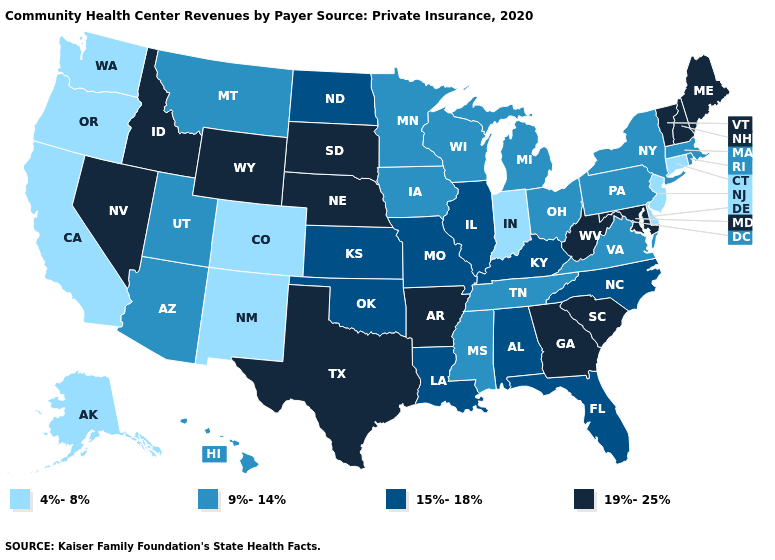Among the states that border New Hampshire , which have the lowest value?
Short answer required. Massachusetts. Does the first symbol in the legend represent the smallest category?
Answer briefly. Yes. Does Connecticut have a lower value than Delaware?
Quick response, please. No. Name the states that have a value in the range 19%-25%?
Give a very brief answer. Arkansas, Georgia, Idaho, Maine, Maryland, Nebraska, Nevada, New Hampshire, South Carolina, South Dakota, Texas, Vermont, West Virginia, Wyoming. What is the value of Wyoming?
Keep it brief. 19%-25%. Does Wyoming have the lowest value in the West?
Concise answer only. No. What is the value of Vermont?
Quick response, please. 19%-25%. Which states have the lowest value in the Northeast?
Quick response, please. Connecticut, New Jersey. Among the states that border Minnesota , does South Dakota have the lowest value?
Short answer required. No. Name the states that have a value in the range 9%-14%?
Quick response, please. Arizona, Hawaii, Iowa, Massachusetts, Michigan, Minnesota, Mississippi, Montana, New York, Ohio, Pennsylvania, Rhode Island, Tennessee, Utah, Virginia, Wisconsin. Name the states that have a value in the range 9%-14%?
Answer briefly. Arizona, Hawaii, Iowa, Massachusetts, Michigan, Minnesota, Mississippi, Montana, New York, Ohio, Pennsylvania, Rhode Island, Tennessee, Utah, Virginia, Wisconsin. Name the states that have a value in the range 9%-14%?
Be succinct. Arizona, Hawaii, Iowa, Massachusetts, Michigan, Minnesota, Mississippi, Montana, New York, Ohio, Pennsylvania, Rhode Island, Tennessee, Utah, Virginia, Wisconsin. What is the value of Alaska?
Answer briefly. 4%-8%. How many symbols are there in the legend?
Quick response, please. 4. 